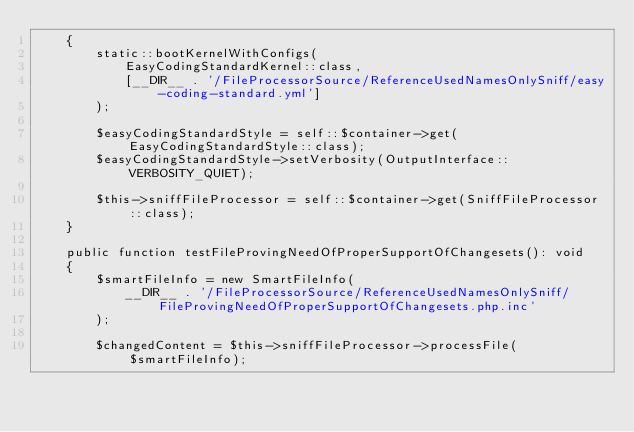Convert code to text. <code><loc_0><loc_0><loc_500><loc_500><_PHP_>    {
        static::bootKernelWithConfigs(
            EasyCodingStandardKernel::class,
            [__DIR__ . '/FileProcessorSource/ReferenceUsedNamesOnlySniff/easy-coding-standard.yml']
        );

        $easyCodingStandardStyle = self::$container->get(EasyCodingStandardStyle::class);
        $easyCodingStandardStyle->setVerbosity(OutputInterface::VERBOSITY_QUIET);

        $this->sniffFileProcessor = self::$container->get(SniffFileProcessor::class);
    }

    public function testFileProvingNeedOfProperSupportOfChangesets(): void
    {
        $smartFileInfo = new SmartFileInfo(
            __DIR__ . '/FileProcessorSource/ReferenceUsedNamesOnlySniff/FileProvingNeedOfProperSupportOfChangesets.php.inc'
        );

        $changedContent = $this->sniffFileProcessor->processFile($smartFileInfo);</code> 